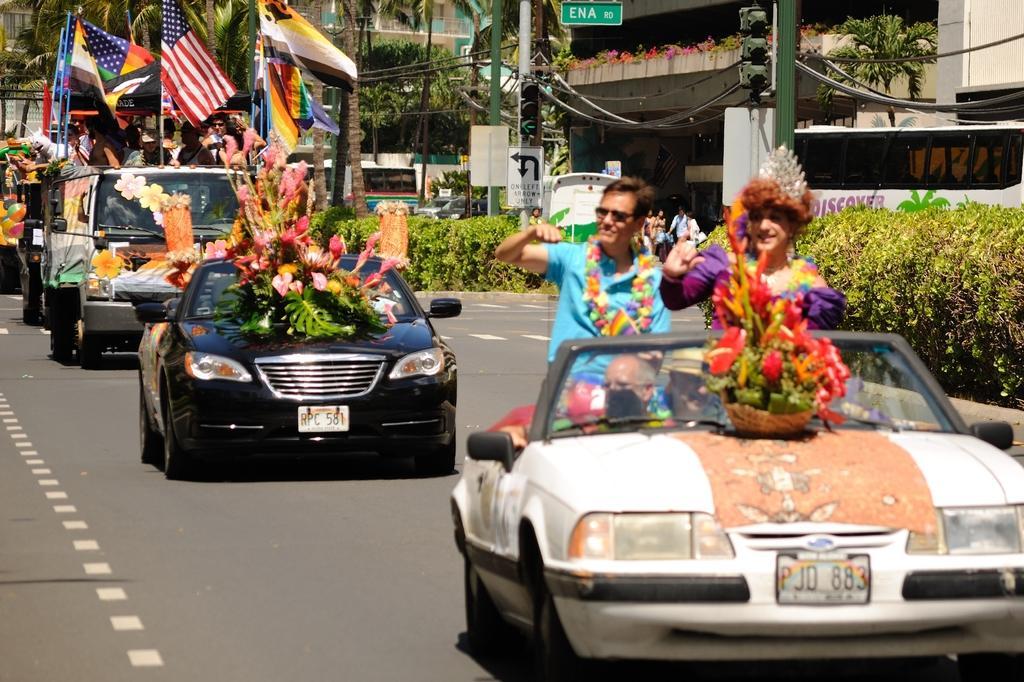Describe this image in one or two sentences. In this image, there is a road which is in black color, in the right side there is a car which is in white color, there are some people sitting in the car, in the middle there is a black color car on that there are some flowers kept,in the right side there are some green color plants, there is a bus which is in white color. 